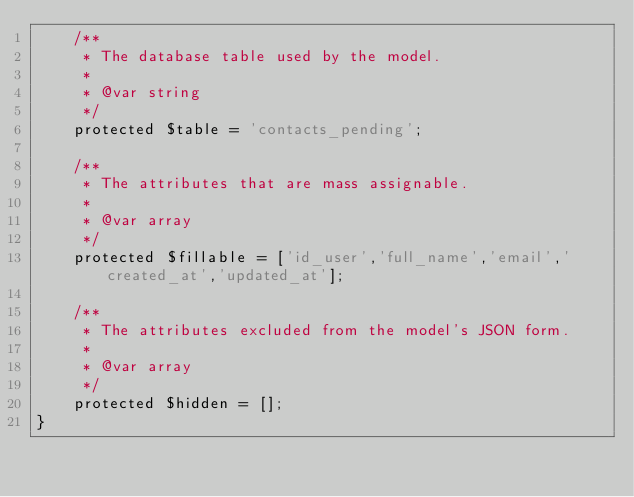Convert code to text. <code><loc_0><loc_0><loc_500><loc_500><_PHP_>    /**
     * The database table used by the model.
     *
     * @var string
     */
    protected $table = 'contacts_pending';

    /**
     * The attributes that are mass assignable.
     *
     * @var array
     */
    protected $fillable = ['id_user','full_name','email','created_at','updated_at'];

    /**
     * The attributes excluded from the model's JSON form.
     *
     * @var array
     */
    protected $hidden = [];
}
</code> 